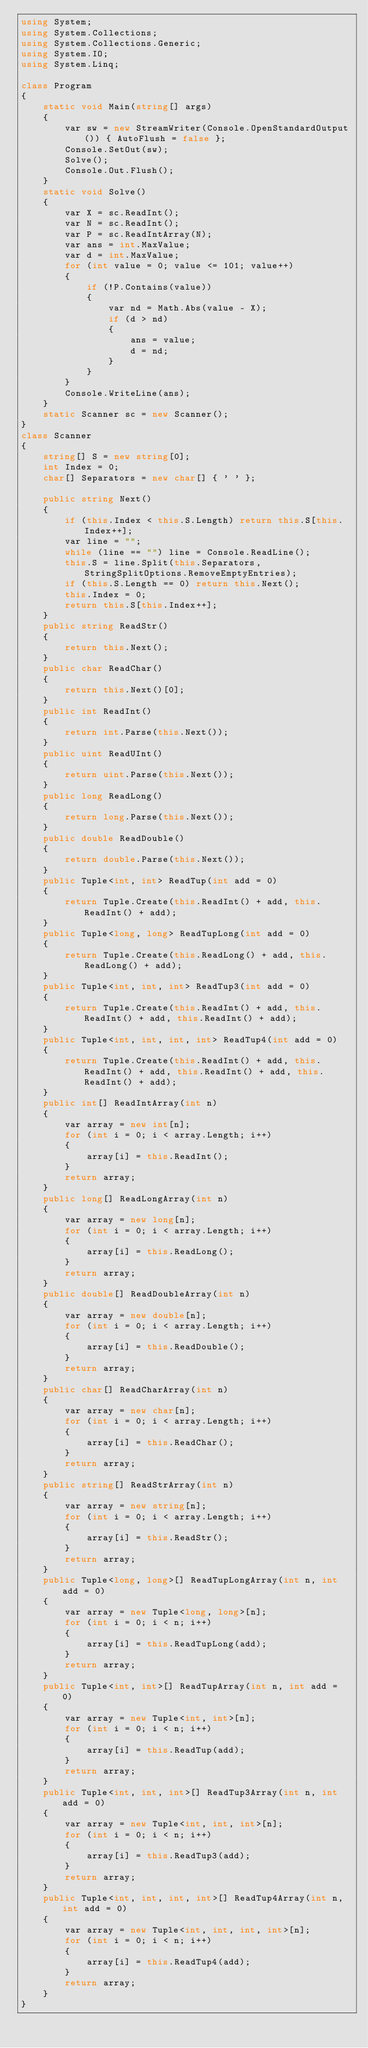<code> <loc_0><loc_0><loc_500><loc_500><_C#_>using System;
using System.Collections;
using System.Collections.Generic;
using System.IO;
using System.Linq;

class Program
{
    static void Main(string[] args)
    {
        var sw = new StreamWriter(Console.OpenStandardOutput()) { AutoFlush = false };
        Console.SetOut(sw);
        Solve();
        Console.Out.Flush();
    }
    static void Solve()
    {
        var X = sc.ReadInt();
        var N = sc.ReadInt();
        var P = sc.ReadIntArray(N);
        var ans = int.MaxValue;
        var d = int.MaxValue;
        for (int value = 0; value <= 101; value++)
        {
            if (!P.Contains(value))
            {
                var nd = Math.Abs(value - X);
                if (d > nd)
                {
                    ans = value;
                    d = nd;
                }
            }
        }
        Console.WriteLine(ans);
    }
    static Scanner sc = new Scanner();
}
class Scanner
{
    string[] S = new string[0];
    int Index = 0;
    char[] Separators = new char[] { ' ' };

    public string Next()
    {
        if (this.Index < this.S.Length) return this.S[this.Index++];
        var line = "";
        while (line == "") line = Console.ReadLine();
        this.S = line.Split(this.Separators, StringSplitOptions.RemoveEmptyEntries);
        if (this.S.Length == 0) return this.Next();
        this.Index = 0;
        return this.S[this.Index++];
    }
    public string ReadStr()
    {
        return this.Next();
    }
    public char ReadChar()
    {
        return this.Next()[0];
    }
    public int ReadInt()
    {
        return int.Parse(this.Next());
    }
    public uint ReadUInt()
    {
        return uint.Parse(this.Next());
    }
    public long ReadLong()
    {
        return long.Parse(this.Next());
    }
    public double ReadDouble()
    {
        return double.Parse(this.Next());
    }
    public Tuple<int, int> ReadTup(int add = 0)
    {
        return Tuple.Create(this.ReadInt() + add, this.ReadInt() + add);
    }
    public Tuple<long, long> ReadTupLong(int add = 0)
    {
        return Tuple.Create(this.ReadLong() + add, this.ReadLong() + add);
    }
    public Tuple<int, int, int> ReadTup3(int add = 0)
    {
        return Tuple.Create(this.ReadInt() + add, this.ReadInt() + add, this.ReadInt() + add);
    }
    public Tuple<int, int, int, int> ReadTup4(int add = 0)
    {
        return Tuple.Create(this.ReadInt() + add, this.ReadInt() + add, this.ReadInt() + add, this.ReadInt() + add);
    }
    public int[] ReadIntArray(int n)
    {
        var array = new int[n];
        for (int i = 0; i < array.Length; i++)
        {
            array[i] = this.ReadInt();
        }
        return array;
    }
    public long[] ReadLongArray(int n)
    {
        var array = new long[n];
        for (int i = 0; i < array.Length; i++)
        {
            array[i] = this.ReadLong();
        }
        return array;
    }
    public double[] ReadDoubleArray(int n)
    {
        var array = new double[n];
        for (int i = 0; i < array.Length; i++)
        {
            array[i] = this.ReadDouble();
        }
        return array;
    }
    public char[] ReadCharArray(int n)
    {
        var array = new char[n];
        for (int i = 0; i < array.Length; i++)
        {
            array[i] = this.ReadChar();
        }
        return array;
    }
    public string[] ReadStrArray(int n)
    {
        var array = new string[n];
        for (int i = 0; i < array.Length; i++)
        {
            array[i] = this.ReadStr();
        }
        return array;
    }
    public Tuple<long, long>[] ReadTupLongArray(int n, int add = 0)
    {
        var array = new Tuple<long, long>[n];
        for (int i = 0; i < n; i++)
        {
            array[i] = this.ReadTupLong(add);
        }
        return array;
    }
    public Tuple<int, int>[] ReadTupArray(int n, int add = 0)
    {
        var array = new Tuple<int, int>[n];
        for (int i = 0; i < n; i++)
        {
            array[i] = this.ReadTup(add);
        }
        return array;
    }
    public Tuple<int, int, int>[] ReadTup3Array(int n, int add = 0)
    {
        var array = new Tuple<int, int, int>[n];
        for (int i = 0; i < n; i++)
        {
            array[i] = this.ReadTup3(add);
        }
        return array;
    }
    public Tuple<int, int, int, int>[] ReadTup4Array(int n, int add = 0)
    {
        var array = new Tuple<int, int, int, int>[n];
        for (int i = 0; i < n; i++)
        {
            array[i] = this.ReadTup4(add);
        }
        return array;
    }
}
</code> 